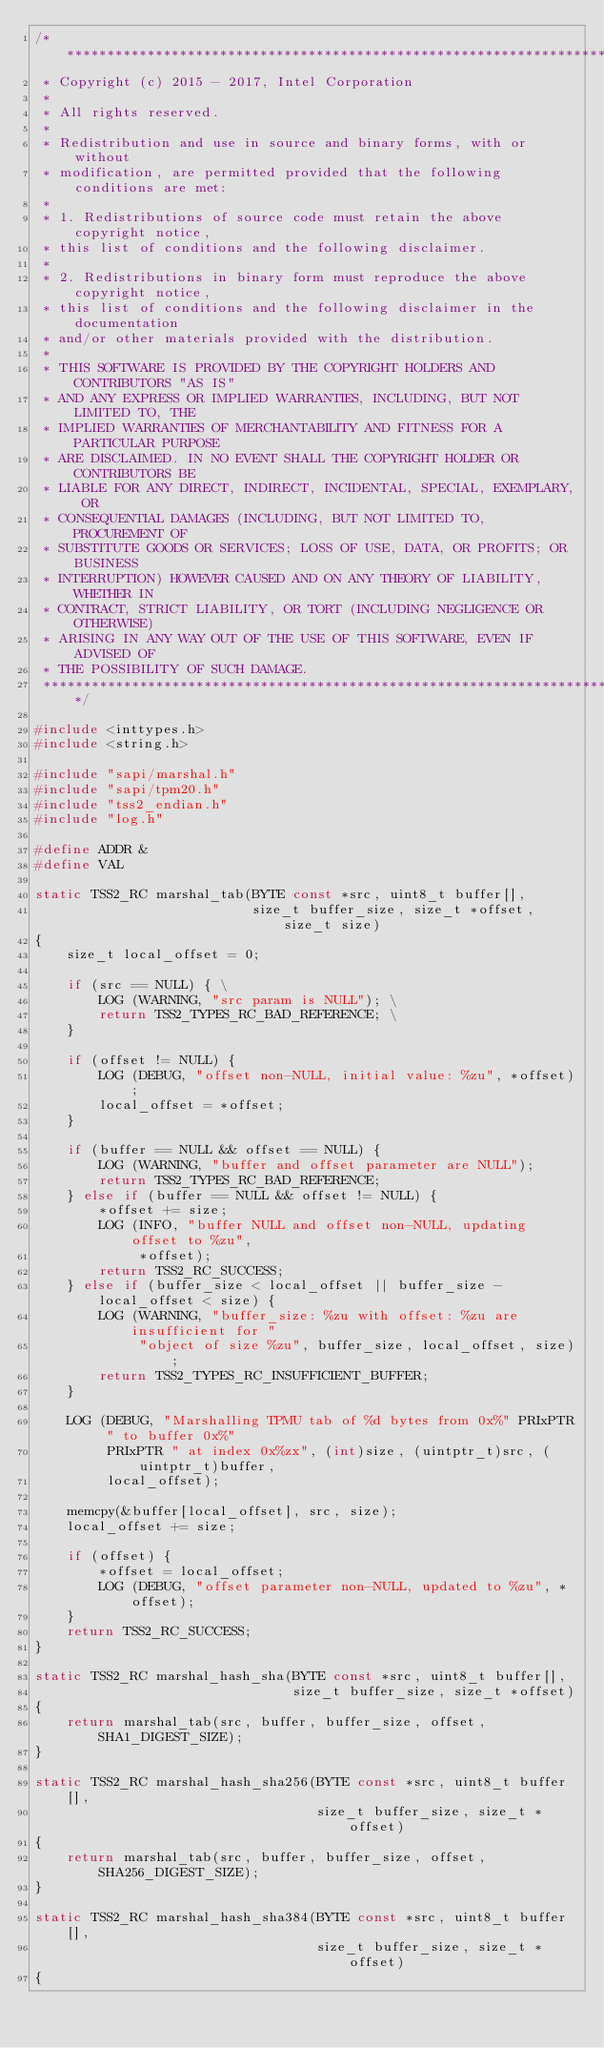<code> <loc_0><loc_0><loc_500><loc_500><_C_>/***********************************************************************
 * Copyright (c) 2015 - 2017, Intel Corporation
 *
 * All rights reserved.
 *
 * Redistribution and use in source and binary forms, with or without
 * modification, are permitted provided that the following conditions are met:
 *
 * 1. Redistributions of source code must retain the above copyright notice,
 * this list of conditions and the following disclaimer.
 *
 * 2. Redistributions in binary form must reproduce the above copyright notice,
 * this list of conditions and the following disclaimer in the documentation
 * and/or other materials provided with the distribution.
 *
 * THIS SOFTWARE IS PROVIDED BY THE COPYRIGHT HOLDERS AND CONTRIBUTORS "AS IS"
 * AND ANY EXPRESS OR IMPLIED WARRANTIES, INCLUDING, BUT NOT LIMITED TO, THE
 * IMPLIED WARRANTIES OF MERCHANTABILITY AND FITNESS FOR A PARTICULAR PURPOSE
 * ARE DISCLAIMED. IN NO EVENT SHALL THE COPYRIGHT HOLDER OR CONTRIBUTORS BE
 * LIABLE FOR ANY DIRECT, INDIRECT, INCIDENTAL, SPECIAL, EXEMPLARY, OR
 * CONSEQUENTIAL DAMAGES (INCLUDING, BUT NOT LIMITED TO, PROCUREMENT OF
 * SUBSTITUTE GOODS OR SERVICES; LOSS OF USE, DATA, OR PROFITS; OR BUSINESS
 * INTERRUPTION) HOWEVER CAUSED AND ON ANY THEORY OF LIABILITY, WHETHER IN
 * CONTRACT, STRICT LIABILITY, OR TORT (INCLUDING NEGLIGENCE OR OTHERWISE)
 * ARISING IN ANY WAY OUT OF THE USE OF THIS SOFTWARE, EVEN IF ADVISED OF
 * THE POSSIBILITY OF SUCH DAMAGE.
 ***********************************************************************/

#include <inttypes.h>
#include <string.h>

#include "sapi/marshal.h"
#include "sapi/tpm20.h"
#include "tss2_endian.h"
#include "log.h"

#define ADDR &
#define VAL

static TSS2_RC marshal_tab(BYTE const *src, uint8_t buffer[],
                           size_t buffer_size, size_t *offset, size_t size)
{
    size_t local_offset = 0;

    if (src == NULL) { \
        LOG (WARNING, "src param is NULL"); \
        return TSS2_TYPES_RC_BAD_REFERENCE; \
    }

    if (offset != NULL) {
        LOG (DEBUG, "offset non-NULL, initial value: %zu", *offset);
        local_offset = *offset;
    }

    if (buffer == NULL && offset == NULL) {
        LOG (WARNING, "buffer and offset parameter are NULL");
        return TSS2_TYPES_RC_BAD_REFERENCE;
    } else if (buffer == NULL && offset != NULL) {
        *offset += size;
        LOG (INFO, "buffer NULL and offset non-NULL, updating offset to %zu",
             *offset);
        return TSS2_RC_SUCCESS;
    } else if (buffer_size < local_offset || buffer_size - local_offset < size) {
        LOG (WARNING, "buffer_size: %zu with offset: %zu are insufficient for "
             "object of size %zu", buffer_size, local_offset, size);
        return TSS2_TYPES_RC_INSUFFICIENT_BUFFER;
    }

    LOG (DEBUG, "Marshalling TPMU tab of %d bytes from 0x%" PRIxPTR " to buffer 0x%"
         PRIxPTR " at index 0x%zx", (int)size, (uintptr_t)src, (uintptr_t)buffer,
         local_offset);

    memcpy(&buffer[local_offset], src, size);
    local_offset += size;

    if (offset) {
        *offset = local_offset;
        LOG (DEBUG, "offset parameter non-NULL, updated to %zu", *offset);
    }
    return TSS2_RC_SUCCESS;
}

static TSS2_RC marshal_hash_sha(BYTE const *src, uint8_t buffer[],
                                size_t buffer_size, size_t *offset)
{
    return marshal_tab(src, buffer, buffer_size, offset, SHA1_DIGEST_SIZE);
}

static TSS2_RC marshal_hash_sha256(BYTE const *src, uint8_t buffer[],
                                   size_t buffer_size, size_t *offset)
{
    return marshal_tab(src, buffer, buffer_size, offset, SHA256_DIGEST_SIZE);
}

static TSS2_RC marshal_hash_sha384(BYTE const *src, uint8_t buffer[],
                                   size_t buffer_size, size_t *offset)
{</code> 